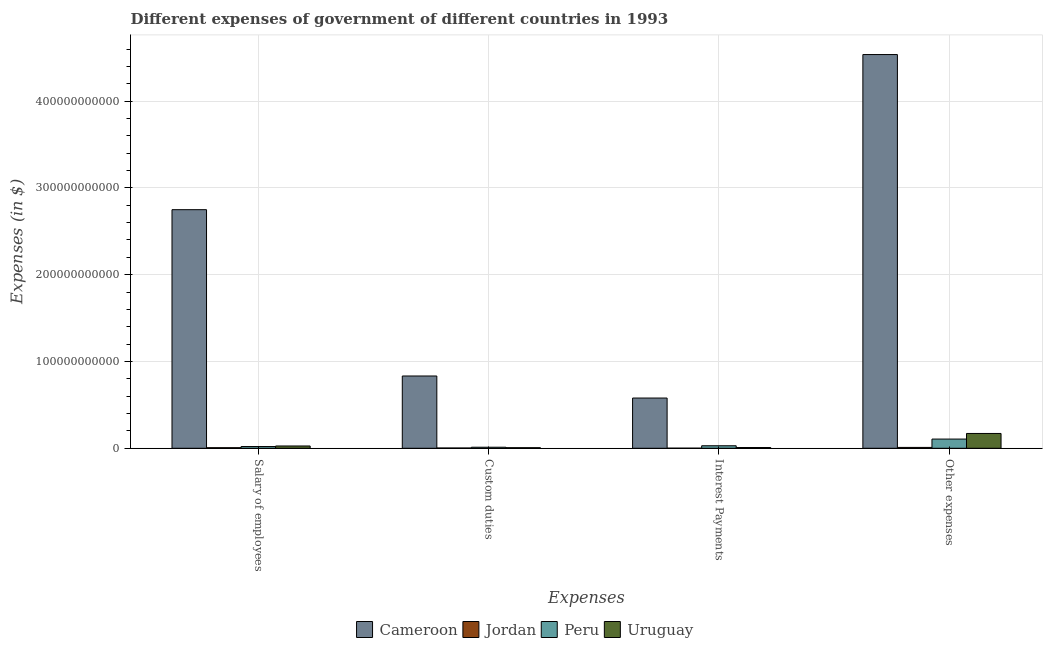How many groups of bars are there?
Offer a very short reply. 4. Are the number of bars on each tick of the X-axis equal?
Give a very brief answer. Yes. How many bars are there on the 3rd tick from the left?
Make the answer very short. 4. What is the label of the 1st group of bars from the left?
Keep it short and to the point. Salary of employees. What is the amount spent on custom duties in Uruguay?
Your answer should be compact. 6.73e+08. Across all countries, what is the maximum amount spent on other expenses?
Ensure brevity in your answer.  4.54e+11. Across all countries, what is the minimum amount spent on salary of employees?
Your answer should be very brief. 6.68e+08. In which country was the amount spent on other expenses maximum?
Your response must be concise. Cameroon. In which country was the amount spent on other expenses minimum?
Your answer should be compact. Jordan. What is the total amount spent on salary of employees in the graph?
Offer a very short reply. 2.80e+11. What is the difference between the amount spent on other expenses in Uruguay and that in Jordan?
Offer a very short reply. 1.61e+1. What is the difference between the amount spent on salary of employees in Uruguay and the amount spent on custom duties in Cameroon?
Your response must be concise. -8.06e+1. What is the average amount spent on custom duties per country?
Make the answer very short. 2.14e+1. What is the difference between the amount spent on interest payments and amount spent on salary of employees in Uruguay?
Provide a succinct answer. -1.78e+09. What is the ratio of the amount spent on interest payments in Uruguay to that in Peru?
Offer a terse response. 0.3. Is the amount spent on other expenses in Uruguay less than that in Jordan?
Ensure brevity in your answer.  No. What is the difference between the highest and the second highest amount spent on custom duties?
Provide a short and direct response. 8.21e+1. What is the difference between the highest and the lowest amount spent on interest payments?
Your response must be concise. 5.78e+1. In how many countries, is the amount spent on other expenses greater than the average amount spent on other expenses taken over all countries?
Ensure brevity in your answer.  1. Is it the case that in every country, the sum of the amount spent on custom duties and amount spent on interest payments is greater than the sum of amount spent on other expenses and amount spent on salary of employees?
Your answer should be compact. No. What does the 2nd bar from the right in Interest Payments represents?
Your answer should be very brief. Peru. Are all the bars in the graph horizontal?
Provide a succinct answer. No. What is the difference between two consecutive major ticks on the Y-axis?
Ensure brevity in your answer.  1.00e+11. Are the values on the major ticks of Y-axis written in scientific E-notation?
Provide a short and direct response. No. Where does the legend appear in the graph?
Your answer should be compact. Bottom center. How many legend labels are there?
Offer a terse response. 4. How are the legend labels stacked?
Offer a terse response. Horizontal. What is the title of the graph?
Keep it short and to the point. Different expenses of government of different countries in 1993. Does "China" appear as one of the legend labels in the graph?
Keep it short and to the point. No. What is the label or title of the X-axis?
Offer a very short reply. Expenses. What is the label or title of the Y-axis?
Keep it short and to the point. Expenses (in $). What is the Expenses (in $) in Cameroon in Salary of employees?
Give a very brief answer. 2.75e+11. What is the Expenses (in $) in Jordan in Salary of employees?
Your answer should be compact. 6.68e+08. What is the Expenses (in $) of Peru in Salary of employees?
Offer a terse response. 2.00e+09. What is the Expenses (in $) of Uruguay in Salary of employees?
Make the answer very short. 2.65e+09. What is the Expenses (in $) of Cameroon in Custom duties?
Offer a very short reply. 8.33e+1. What is the Expenses (in $) of Jordan in Custom duties?
Make the answer very short. 3.38e+08. What is the Expenses (in $) of Peru in Custom duties?
Your answer should be very brief. 1.21e+09. What is the Expenses (in $) of Uruguay in Custom duties?
Provide a short and direct response. 6.73e+08. What is the Expenses (in $) in Cameroon in Interest Payments?
Your answer should be compact. 5.79e+1. What is the Expenses (in $) in Jordan in Interest Payments?
Your response must be concise. 1.22e+08. What is the Expenses (in $) in Peru in Interest Payments?
Your answer should be very brief. 2.90e+09. What is the Expenses (in $) in Uruguay in Interest Payments?
Your response must be concise. 8.66e+08. What is the Expenses (in $) in Cameroon in Other expenses?
Give a very brief answer. 4.54e+11. What is the Expenses (in $) of Jordan in Other expenses?
Your answer should be very brief. 1.01e+09. What is the Expenses (in $) of Peru in Other expenses?
Make the answer very short. 1.06e+1. What is the Expenses (in $) of Uruguay in Other expenses?
Your answer should be very brief. 1.71e+1. Across all Expenses, what is the maximum Expenses (in $) of Cameroon?
Offer a terse response. 4.54e+11. Across all Expenses, what is the maximum Expenses (in $) of Jordan?
Keep it short and to the point. 1.01e+09. Across all Expenses, what is the maximum Expenses (in $) in Peru?
Ensure brevity in your answer.  1.06e+1. Across all Expenses, what is the maximum Expenses (in $) in Uruguay?
Ensure brevity in your answer.  1.71e+1. Across all Expenses, what is the minimum Expenses (in $) in Cameroon?
Provide a succinct answer. 5.79e+1. Across all Expenses, what is the minimum Expenses (in $) of Jordan?
Make the answer very short. 1.22e+08. Across all Expenses, what is the minimum Expenses (in $) of Peru?
Keep it short and to the point. 1.21e+09. Across all Expenses, what is the minimum Expenses (in $) in Uruguay?
Your answer should be very brief. 6.73e+08. What is the total Expenses (in $) in Cameroon in the graph?
Your answer should be compact. 8.70e+11. What is the total Expenses (in $) of Jordan in the graph?
Ensure brevity in your answer.  2.13e+09. What is the total Expenses (in $) of Peru in the graph?
Your answer should be very brief. 1.67e+1. What is the total Expenses (in $) of Uruguay in the graph?
Offer a terse response. 2.13e+1. What is the difference between the Expenses (in $) of Cameroon in Salary of employees and that in Custom duties?
Your answer should be very brief. 1.92e+11. What is the difference between the Expenses (in $) of Jordan in Salary of employees and that in Custom duties?
Provide a succinct answer. 3.31e+08. What is the difference between the Expenses (in $) in Peru in Salary of employees and that in Custom duties?
Make the answer very short. 7.89e+08. What is the difference between the Expenses (in $) in Uruguay in Salary of employees and that in Custom duties?
Provide a succinct answer. 1.97e+09. What is the difference between the Expenses (in $) of Cameroon in Salary of employees and that in Interest Payments?
Your answer should be compact. 2.17e+11. What is the difference between the Expenses (in $) of Jordan in Salary of employees and that in Interest Payments?
Provide a succinct answer. 5.46e+08. What is the difference between the Expenses (in $) in Peru in Salary of employees and that in Interest Payments?
Keep it short and to the point. -9.03e+08. What is the difference between the Expenses (in $) in Uruguay in Salary of employees and that in Interest Payments?
Keep it short and to the point. 1.78e+09. What is the difference between the Expenses (in $) in Cameroon in Salary of employees and that in Other expenses?
Your answer should be compact. -1.79e+11. What is the difference between the Expenses (in $) of Jordan in Salary of employees and that in Other expenses?
Your response must be concise. -3.37e+08. What is the difference between the Expenses (in $) in Peru in Salary of employees and that in Other expenses?
Provide a succinct answer. -8.61e+09. What is the difference between the Expenses (in $) in Uruguay in Salary of employees and that in Other expenses?
Offer a terse response. -1.44e+1. What is the difference between the Expenses (in $) in Cameroon in Custom duties and that in Interest Payments?
Your answer should be compact. 2.54e+1. What is the difference between the Expenses (in $) of Jordan in Custom duties and that in Interest Payments?
Provide a succinct answer. 2.16e+08. What is the difference between the Expenses (in $) of Peru in Custom duties and that in Interest Payments?
Make the answer very short. -1.69e+09. What is the difference between the Expenses (in $) in Uruguay in Custom duties and that in Interest Payments?
Offer a very short reply. -1.93e+08. What is the difference between the Expenses (in $) in Cameroon in Custom duties and that in Other expenses?
Provide a succinct answer. -3.70e+11. What is the difference between the Expenses (in $) in Jordan in Custom duties and that in Other expenses?
Ensure brevity in your answer.  -6.68e+08. What is the difference between the Expenses (in $) in Peru in Custom duties and that in Other expenses?
Offer a terse response. -9.40e+09. What is the difference between the Expenses (in $) in Uruguay in Custom duties and that in Other expenses?
Keep it short and to the point. -1.64e+1. What is the difference between the Expenses (in $) of Cameroon in Interest Payments and that in Other expenses?
Your response must be concise. -3.96e+11. What is the difference between the Expenses (in $) in Jordan in Interest Payments and that in Other expenses?
Your answer should be compact. -8.84e+08. What is the difference between the Expenses (in $) in Peru in Interest Payments and that in Other expenses?
Offer a very short reply. -7.70e+09. What is the difference between the Expenses (in $) of Uruguay in Interest Payments and that in Other expenses?
Offer a terse response. -1.62e+1. What is the difference between the Expenses (in $) in Cameroon in Salary of employees and the Expenses (in $) in Jordan in Custom duties?
Your response must be concise. 2.75e+11. What is the difference between the Expenses (in $) of Cameroon in Salary of employees and the Expenses (in $) of Peru in Custom duties?
Your answer should be very brief. 2.74e+11. What is the difference between the Expenses (in $) in Cameroon in Salary of employees and the Expenses (in $) in Uruguay in Custom duties?
Keep it short and to the point. 2.74e+11. What is the difference between the Expenses (in $) of Jordan in Salary of employees and the Expenses (in $) of Peru in Custom duties?
Your answer should be very brief. -5.42e+08. What is the difference between the Expenses (in $) of Jordan in Salary of employees and the Expenses (in $) of Uruguay in Custom duties?
Keep it short and to the point. -4.58e+06. What is the difference between the Expenses (in $) in Peru in Salary of employees and the Expenses (in $) in Uruguay in Custom duties?
Your answer should be very brief. 1.33e+09. What is the difference between the Expenses (in $) in Cameroon in Salary of employees and the Expenses (in $) in Jordan in Interest Payments?
Provide a succinct answer. 2.75e+11. What is the difference between the Expenses (in $) in Cameroon in Salary of employees and the Expenses (in $) in Peru in Interest Payments?
Your answer should be very brief. 2.72e+11. What is the difference between the Expenses (in $) of Cameroon in Salary of employees and the Expenses (in $) of Uruguay in Interest Payments?
Make the answer very short. 2.74e+11. What is the difference between the Expenses (in $) in Jordan in Salary of employees and the Expenses (in $) in Peru in Interest Payments?
Your response must be concise. -2.23e+09. What is the difference between the Expenses (in $) in Jordan in Salary of employees and the Expenses (in $) in Uruguay in Interest Payments?
Offer a terse response. -1.98e+08. What is the difference between the Expenses (in $) in Peru in Salary of employees and the Expenses (in $) in Uruguay in Interest Payments?
Give a very brief answer. 1.13e+09. What is the difference between the Expenses (in $) of Cameroon in Salary of employees and the Expenses (in $) of Jordan in Other expenses?
Your answer should be very brief. 2.74e+11. What is the difference between the Expenses (in $) of Cameroon in Salary of employees and the Expenses (in $) of Peru in Other expenses?
Provide a short and direct response. 2.64e+11. What is the difference between the Expenses (in $) of Cameroon in Salary of employees and the Expenses (in $) of Uruguay in Other expenses?
Provide a short and direct response. 2.58e+11. What is the difference between the Expenses (in $) of Jordan in Salary of employees and the Expenses (in $) of Peru in Other expenses?
Provide a short and direct response. -9.94e+09. What is the difference between the Expenses (in $) in Jordan in Salary of employees and the Expenses (in $) in Uruguay in Other expenses?
Your answer should be very brief. -1.64e+1. What is the difference between the Expenses (in $) in Peru in Salary of employees and the Expenses (in $) in Uruguay in Other expenses?
Your answer should be very brief. -1.51e+1. What is the difference between the Expenses (in $) in Cameroon in Custom duties and the Expenses (in $) in Jordan in Interest Payments?
Your answer should be very brief. 8.32e+1. What is the difference between the Expenses (in $) of Cameroon in Custom duties and the Expenses (in $) of Peru in Interest Payments?
Your answer should be compact. 8.04e+1. What is the difference between the Expenses (in $) of Cameroon in Custom duties and the Expenses (in $) of Uruguay in Interest Payments?
Keep it short and to the point. 8.24e+1. What is the difference between the Expenses (in $) in Jordan in Custom duties and the Expenses (in $) in Peru in Interest Payments?
Keep it short and to the point. -2.56e+09. What is the difference between the Expenses (in $) of Jordan in Custom duties and the Expenses (in $) of Uruguay in Interest Payments?
Offer a very short reply. -5.28e+08. What is the difference between the Expenses (in $) in Peru in Custom duties and the Expenses (in $) in Uruguay in Interest Payments?
Your response must be concise. 3.44e+08. What is the difference between the Expenses (in $) of Cameroon in Custom duties and the Expenses (in $) of Jordan in Other expenses?
Provide a short and direct response. 8.23e+1. What is the difference between the Expenses (in $) in Cameroon in Custom duties and the Expenses (in $) in Peru in Other expenses?
Give a very brief answer. 7.27e+1. What is the difference between the Expenses (in $) in Cameroon in Custom duties and the Expenses (in $) in Uruguay in Other expenses?
Your answer should be very brief. 6.62e+1. What is the difference between the Expenses (in $) of Jordan in Custom duties and the Expenses (in $) of Peru in Other expenses?
Provide a succinct answer. -1.03e+1. What is the difference between the Expenses (in $) in Jordan in Custom duties and the Expenses (in $) in Uruguay in Other expenses?
Your response must be concise. -1.67e+1. What is the difference between the Expenses (in $) in Peru in Custom duties and the Expenses (in $) in Uruguay in Other expenses?
Your answer should be compact. -1.59e+1. What is the difference between the Expenses (in $) in Cameroon in Interest Payments and the Expenses (in $) in Jordan in Other expenses?
Offer a very short reply. 5.69e+1. What is the difference between the Expenses (in $) in Cameroon in Interest Payments and the Expenses (in $) in Peru in Other expenses?
Provide a succinct answer. 4.73e+1. What is the difference between the Expenses (in $) in Cameroon in Interest Payments and the Expenses (in $) in Uruguay in Other expenses?
Keep it short and to the point. 4.08e+1. What is the difference between the Expenses (in $) of Jordan in Interest Payments and the Expenses (in $) of Peru in Other expenses?
Ensure brevity in your answer.  -1.05e+1. What is the difference between the Expenses (in $) of Jordan in Interest Payments and the Expenses (in $) of Uruguay in Other expenses?
Provide a succinct answer. -1.70e+1. What is the difference between the Expenses (in $) of Peru in Interest Payments and the Expenses (in $) of Uruguay in Other expenses?
Ensure brevity in your answer.  -1.42e+1. What is the average Expenses (in $) in Cameroon per Expenses?
Keep it short and to the point. 2.17e+11. What is the average Expenses (in $) in Jordan per Expenses?
Provide a short and direct response. 5.33e+08. What is the average Expenses (in $) in Peru per Expenses?
Provide a short and direct response. 4.18e+09. What is the average Expenses (in $) in Uruguay per Expenses?
Make the answer very short. 5.32e+09. What is the difference between the Expenses (in $) of Cameroon and Expenses (in $) of Jordan in Salary of employees?
Provide a short and direct response. 2.74e+11. What is the difference between the Expenses (in $) in Cameroon and Expenses (in $) in Peru in Salary of employees?
Provide a succinct answer. 2.73e+11. What is the difference between the Expenses (in $) of Cameroon and Expenses (in $) of Uruguay in Salary of employees?
Ensure brevity in your answer.  2.72e+11. What is the difference between the Expenses (in $) of Jordan and Expenses (in $) of Peru in Salary of employees?
Provide a short and direct response. -1.33e+09. What is the difference between the Expenses (in $) of Jordan and Expenses (in $) of Uruguay in Salary of employees?
Offer a very short reply. -1.98e+09. What is the difference between the Expenses (in $) of Peru and Expenses (in $) of Uruguay in Salary of employees?
Provide a succinct answer. -6.47e+08. What is the difference between the Expenses (in $) in Cameroon and Expenses (in $) in Jordan in Custom duties?
Give a very brief answer. 8.30e+1. What is the difference between the Expenses (in $) in Cameroon and Expenses (in $) in Peru in Custom duties?
Offer a very short reply. 8.21e+1. What is the difference between the Expenses (in $) in Cameroon and Expenses (in $) in Uruguay in Custom duties?
Make the answer very short. 8.26e+1. What is the difference between the Expenses (in $) of Jordan and Expenses (in $) of Peru in Custom duties?
Offer a terse response. -8.72e+08. What is the difference between the Expenses (in $) of Jordan and Expenses (in $) of Uruguay in Custom duties?
Offer a terse response. -3.35e+08. What is the difference between the Expenses (in $) in Peru and Expenses (in $) in Uruguay in Custom duties?
Your answer should be very brief. 5.37e+08. What is the difference between the Expenses (in $) of Cameroon and Expenses (in $) of Jordan in Interest Payments?
Provide a succinct answer. 5.78e+1. What is the difference between the Expenses (in $) of Cameroon and Expenses (in $) of Peru in Interest Payments?
Ensure brevity in your answer.  5.50e+1. What is the difference between the Expenses (in $) of Cameroon and Expenses (in $) of Uruguay in Interest Payments?
Provide a short and direct response. 5.70e+1. What is the difference between the Expenses (in $) in Jordan and Expenses (in $) in Peru in Interest Payments?
Your response must be concise. -2.78e+09. What is the difference between the Expenses (in $) of Jordan and Expenses (in $) of Uruguay in Interest Payments?
Offer a terse response. -7.44e+08. What is the difference between the Expenses (in $) of Peru and Expenses (in $) of Uruguay in Interest Payments?
Give a very brief answer. 2.04e+09. What is the difference between the Expenses (in $) of Cameroon and Expenses (in $) of Jordan in Other expenses?
Your response must be concise. 4.53e+11. What is the difference between the Expenses (in $) in Cameroon and Expenses (in $) in Peru in Other expenses?
Ensure brevity in your answer.  4.43e+11. What is the difference between the Expenses (in $) of Cameroon and Expenses (in $) of Uruguay in Other expenses?
Offer a very short reply. 4.37e+11. What is the difference between the Expenses (in $) in Jordan and Expenses (in $) in Peru in Other expenses?
Your response must be concise. -9.60e+09. What is the difference between the Expenses (in $) in Jordan and Expenses (in $) in Uruguay in Other expenses?
Provide a short and direct response. -1.61e+1. What is the difference between the Expenses (in $) in Peru and Expenses (in $) in Uruguay in Other expenses?
Give a very brief answer. -6.47e+09. What is the ratio of the Expenses (in $) of Cameroon in Salary of employees to that in Custom duties?
Make the answer very short. 3.3. What is the ratio of the Expenses (in $) of Jordan in Salary of employees to that in Custom duties?
Offer a terse response. 1.98. What is the ratio of the Expenses (in $) in Peru in Salary of employees to that in Custom duties?
Your answer should be compact. 1.65. What is the ratio of the Expenses (in $) of Uruguay in Salary of employees to that in Custom duties?
Offer a very short reply. 3.93. What is the ratio of the Expenses (in $) of Cameroon in Salary of employees to that in Interest Payments?
Your answer should be compact. 4.75. What is the ratio of the Expenses (in $) of Jordan in Salary of employees to that in Interest Payments?
Offer a very short reply. 5.48. What is the ratio of the Expenses (in $) in Peru in Salary of employees to that in Interest Payments?
Give a very brief answer. 0.69. What is the ratio of the Expenses (in $) of Uruguay in Salary of employees to that in Interest Payments?
Your answer should be very brief. 3.06. What is the ratio of the Expenses (in $) in Cameroon in Salary of employees to that in Other expenses?
Your response must be concise. 0.61. What is the ratio of the Expenses (in $) in Jordan in Salary of employees to that in Other expenses?
Provide a succinct answer. 0.66. What is the ratio of the Expenses (in $) in Peru in Salary of employees to that in Other expenses?
Keep it short and to the point. 0.19. What is the ratio of the Expenses (in $) of Uruguay in Salary of employees to that in Other expenses?
Make the answer very short. 0.15. What is the ratio of the Expenses (in $) of Cameroon in Custom duties to that in Interest Payments?
Make the answer very short. 1.44. What is the ratio of the Expenses (in $) of Jordan in Custom duties to that in Interest Payments?
Ensure brevity in your answer.  2.77. What is the ratio of the Expenses (in $) of Peru in Custom duties to that in Interest Payments?
Ensure brevity in your answer.  0.42. What is the ratio of the Expenses (in $) in Uruguay in Custom duties to that in Interest Payments?
Your answer should be compact. 0.78. What is the ratio of the Expenses (in $) in Cameroon in Custom duties to that in Other expenses?
Give a very brief answer. 0.18. What is the ratio of the Expenses (in $) in Jordan in Custom duties to that in Other expenses?
Provide a succinct answer. 0.34. What is the ratio of the Expenses (in $) in Peru in Custom duties to that in Other expenses?
Offer a terse response. 0.11. What is the ratio of the Expenses (in $) of Uruguay in Custom duties to that in Other expenses?
Provide a succinct answer. 0.04. What is the ratio of the Expenses (in $) of Cameroon in Interest Payments to that in Other expenses?
Give a very brief answer. 0.13. What is the ratio of the Expenses (in $) of Jordan in Interest Payments to that in Other expenses?
Provide a succinct answer. 0.12. What is the ratio of the Expenses (in $) of Peru in Interest Payments to that in Other expenses?
Offer a terse response. 0.27. What is the ratio of the Expenses (in $) of Uruguay in Interest Payments to that in Other expenses?
Make the answer very short. 0.05. What is the difference between the highest and the second highest Expenses (in $) of Cameroon?
Make the answer very short. 1.79e+11. What is the difference between the highest and the second highest Expenses (in $) in Jordan?
Ensure brevity in your answer.  3.37e+08. What is the difference between the highest and the second highest Expenses (in $) of Peru?
Make the answer very short. 7.70e+09. What is the difference between the highest and the second highest Expenses (in $) in Uruguay?
Offer a very short reply. 1.44e+1. What is the difference between the highest and the lowest Expenses (in $) of Cameroon?
Make the answer very short. 3.96e+11. What is the difference between the highest and the lowest Expenses (in $) of Jordan?
Provide a short and direct response. 8.84e+08. What is the difference between the highest and the lowest Expenses (in $) of Peru?
Your answer should be very brief. 9.40e+09. What is the difference between the highest and the lowest Expenses (in $) in Uruguay?
Ensure brevity in your answer.  1.64e+1. 